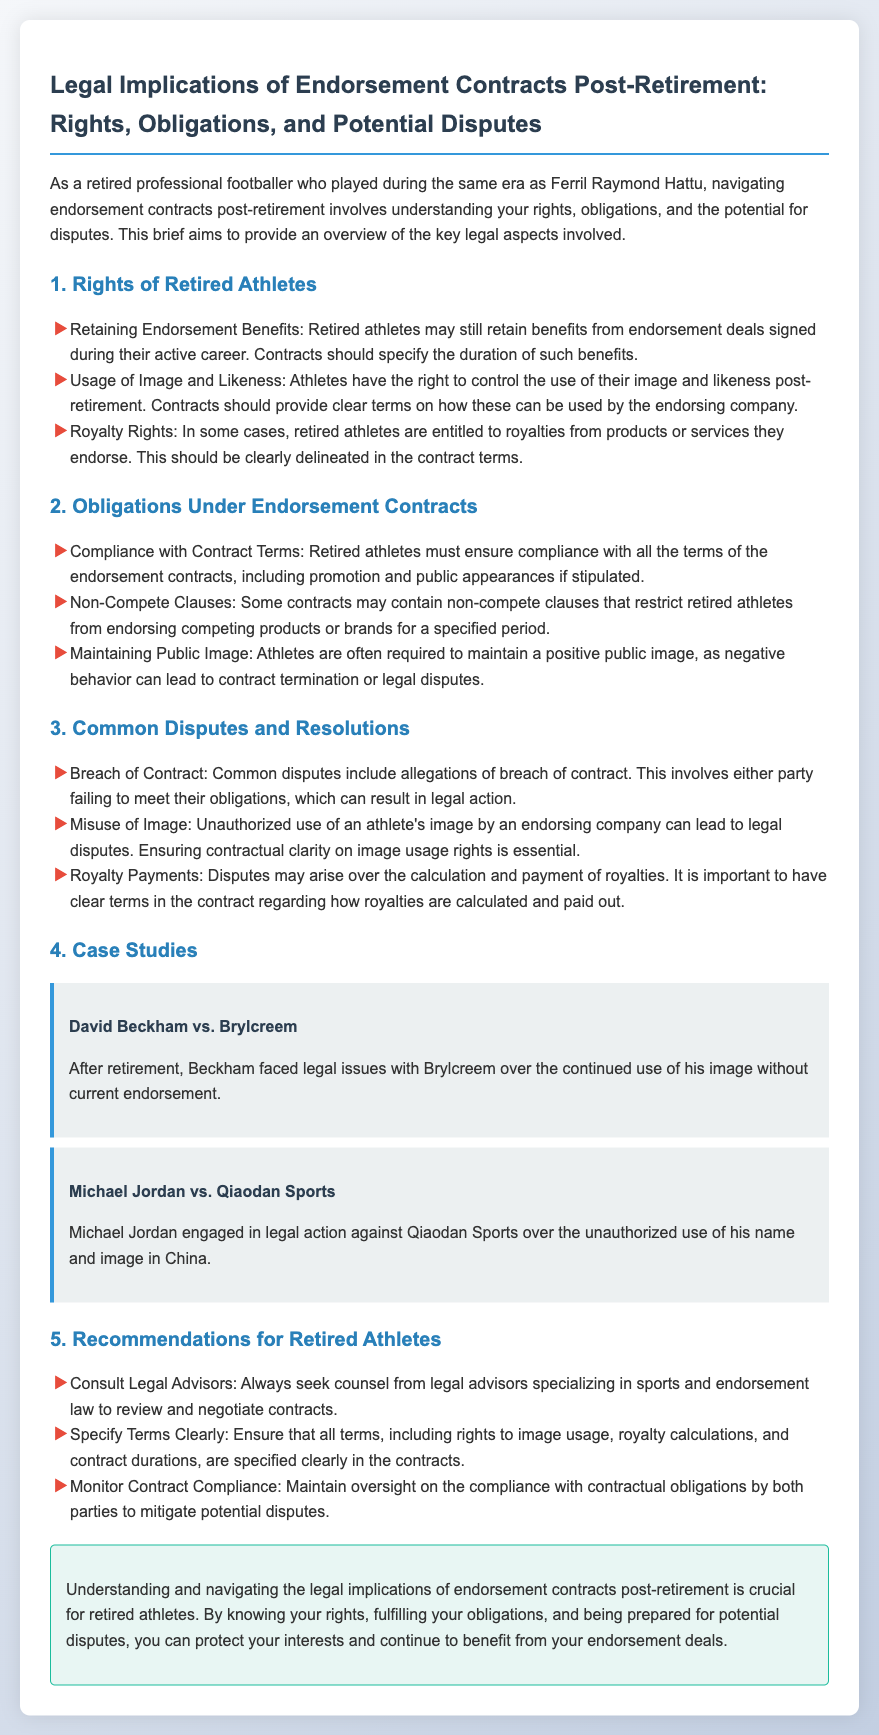What are the rights of retired athletes concerning endorsement benefits? The rights concerning endorsement benefits include retaining endorsement benefits, usage of image and likeness, and royalty rights.
Answer: Retaining endorsement benefits What must retired athletes comply with under endorsement contracts? Compliance involves ensuring adherence to the terms of the endorsement contracts, including any promotion and appearances stipulated.
Answer: Compliance with contract terms What is a common dispute among endorsement contracts? A common dispute involves breach of contract where one party fails to meet their obligations under the contract.
Answer: Breach of contract Which legal case involved David Beckham? The case involving David Beckham is over the continued use of his image without current endorsement.
Answer: David Beckham vs. Brylcreem What should retired athletes do regarding their contracts? Retired athletes should consult legal advisors to review and negotiate contracts effectively.
Answer: Consult legal advisors What is essential to have clear terms on in endorsement contracts? It is essential to have clear terms on image usage rights, royalty calculations, and contract durations in endorsement contracts.
Answer: Image usage rights How can disputes over royalties arise? Disputes can arise over the calculation and payment of royalties if the terms are not clearly delineated in the contract.
Answer: Calculation and payment of royalties What is a recommendation for maintaining compliance with contracts? A recommendation is to monitor contract compliance and ensure both parties adhere to their obligations to avoid disputes.
Answer: Monitor contract compliance 